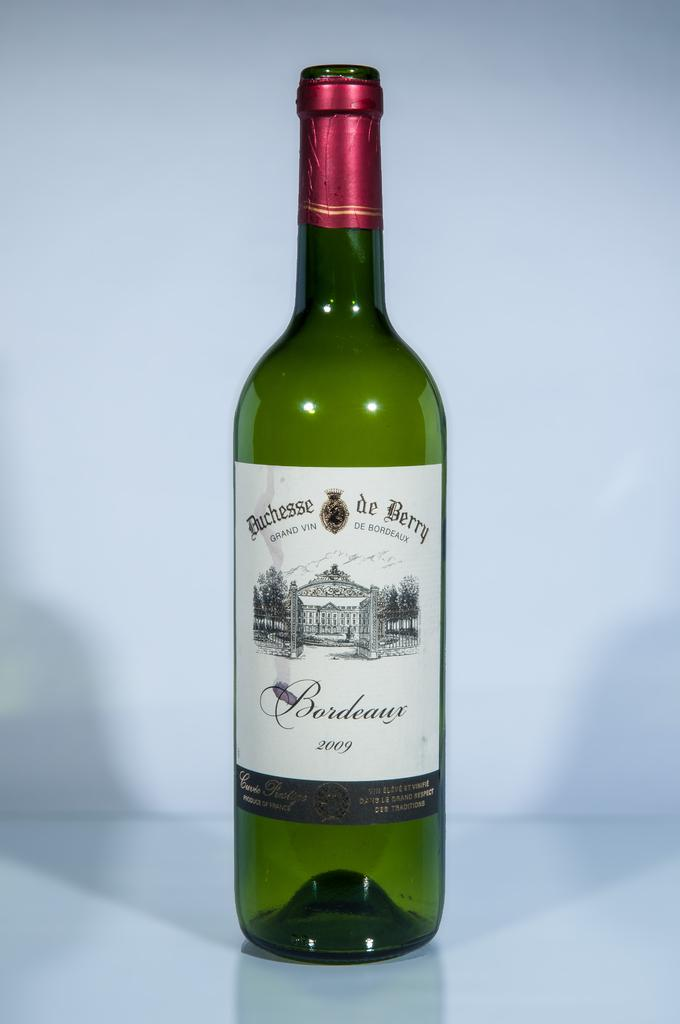<image>
Render a clear and concise summary of the photo. A bottle has the year 2009 near the bottom of the label. 